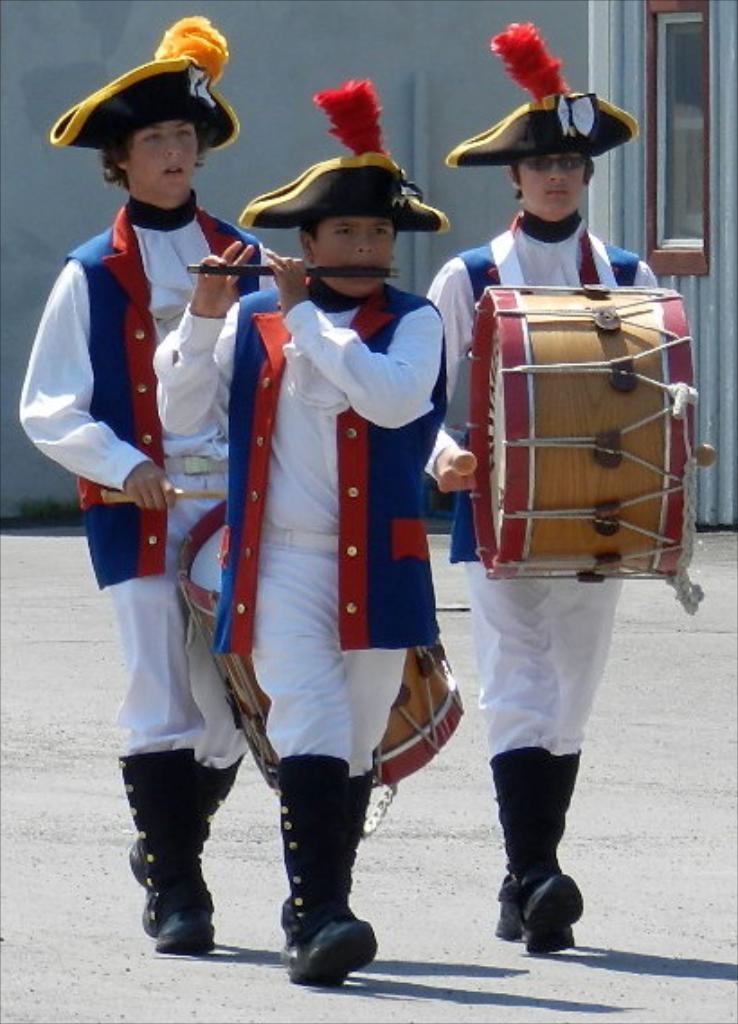How would you summarize this image in a sentence or two? In this picture we can see three men walking with two are playing drums and one is playing flute and they wore caps, jackets and in background we can see wall, window, pipes. 